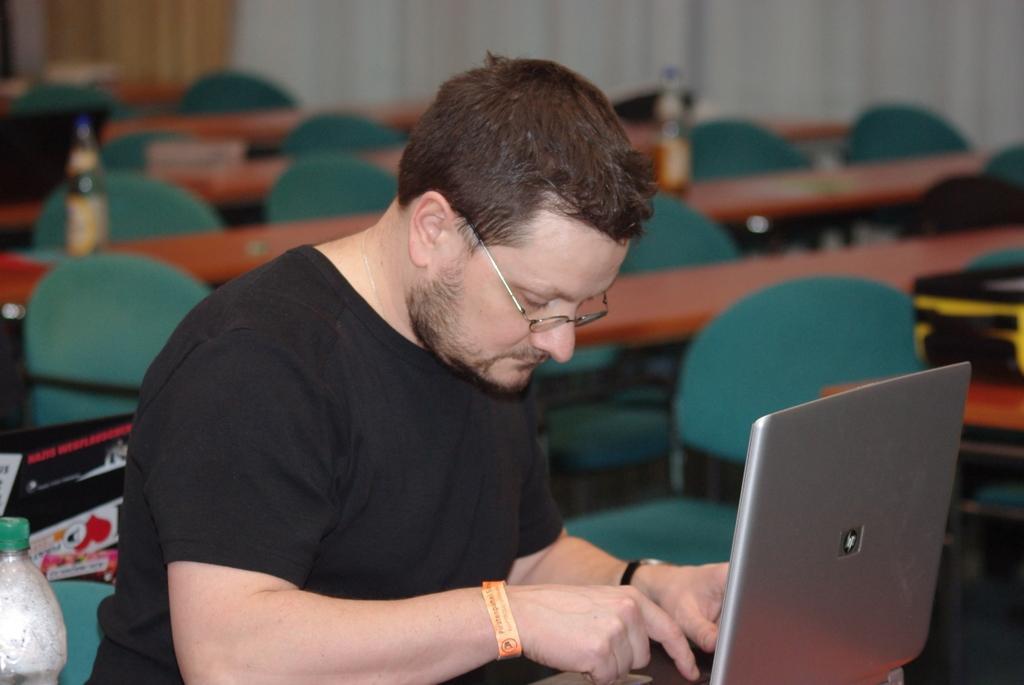In one or two sentences, can you explain what this image depicts? In this image, In the middle there is a man sitting and he is using a laptop which is in ash color, In the background there are some brown color tables and there are some chairs which are in green color. 